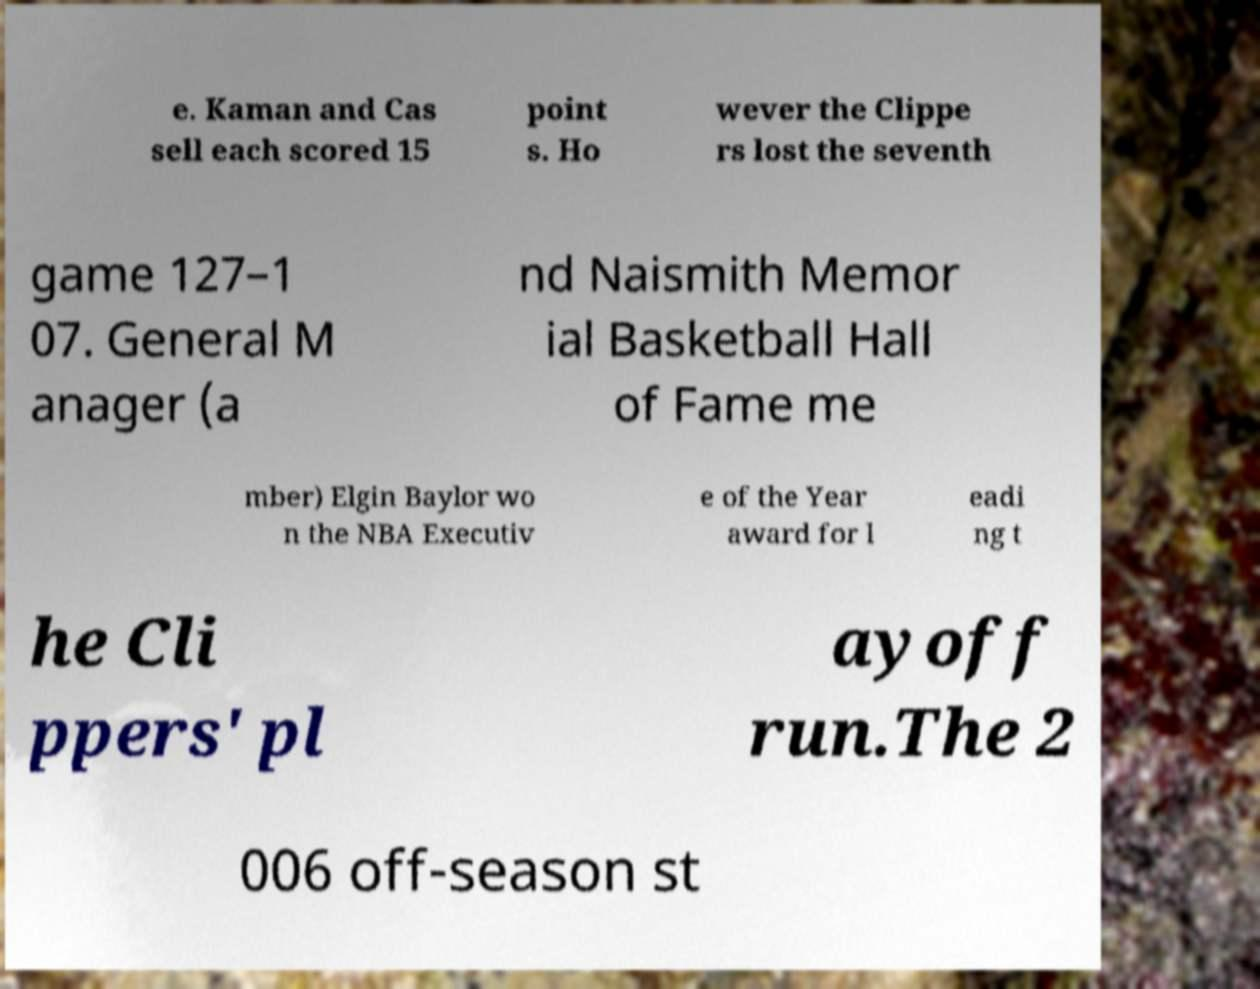What messages or text are displayed in this image? I need them in a readable, typed format. e. Kaman and Cas sell each scored 15 point s. Ho wever the Clippe rs lost the seventh game 127–1 07. General M anager (a nd Naismith Memor ial Basketball Hall of Fame me mber) Elgin Baylor wo n the NBA Executiv e of the Year award for l eadi ng t he Cli ppers' pl ayoff run.The 2 006 off-season st 